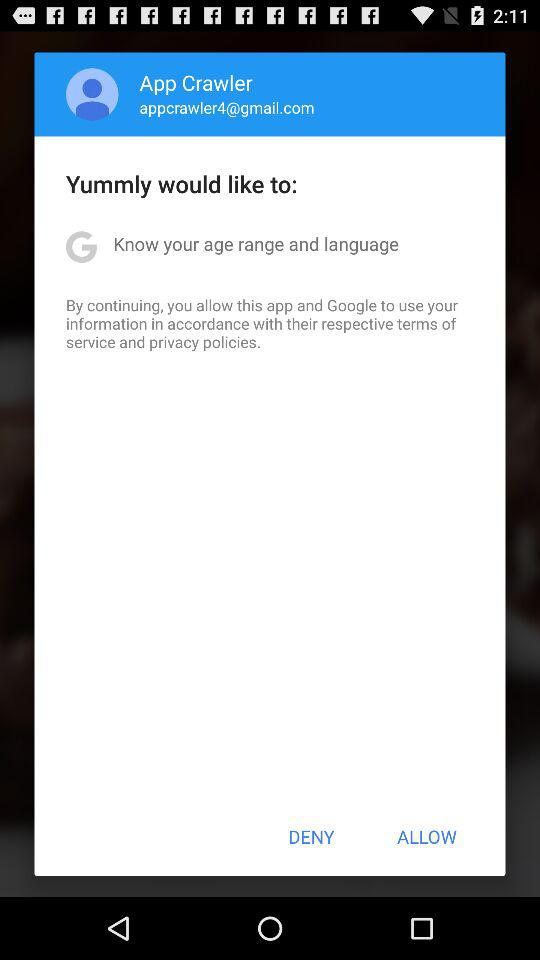What is the name of the user? The name of the user is App Crawler. 